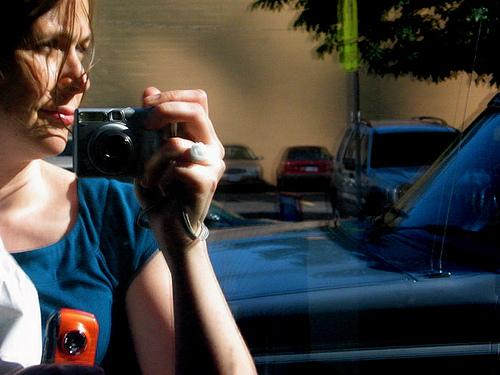What can be done using the orange thing? take pictures 